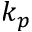Convert formula to latex. <formula><loc_0><loc_0><loc_500><loc_500>k _ { p }</formula> 